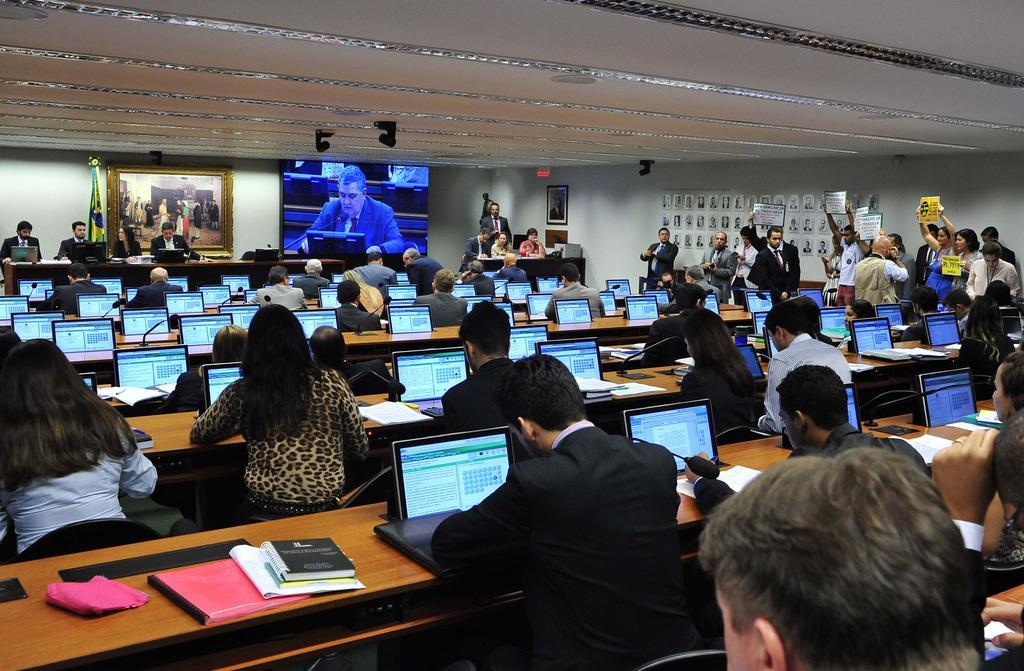Please provide a concise description of this image. In this image I can see group of people sitting and working on the laptop. Background I can see few other persons standing, I can also see a projector screen and I can see a frame attached to the wall and the wall is in white color. 